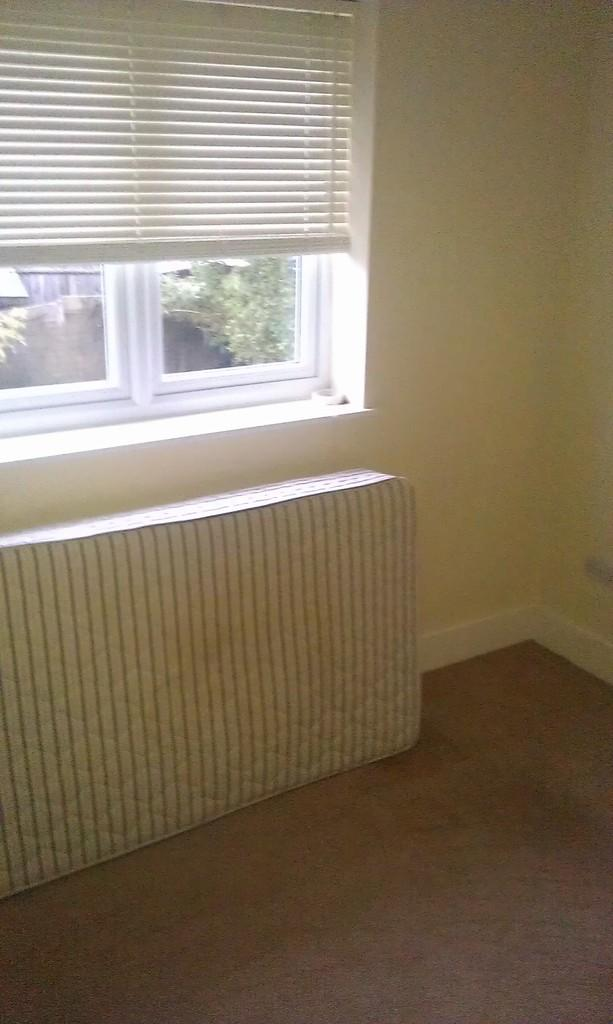What type of space is shown in the image? The image is an inside view of a room. What feature allows natural light to enter the room? There is a window in the room. What is used to cover the window? There is a curtain associated with the window. What is one of the main structural elements of the room? There is a wall in the room. What is a piece of furniture or object for sleeping in the room? There is a mattress in the room. What is the surface that people walk on in the room? There is a floor in the room. What can be seen outside the window? Trees are visible through the window. What other architectural feature can be seen through the window? There is another wall visible through the window. What type of cloud can be seen floating above the mattress in the image? There is no cloud visible in the image; it is an inside view of a room with a window, curtain, wall, mattress, and floor. 